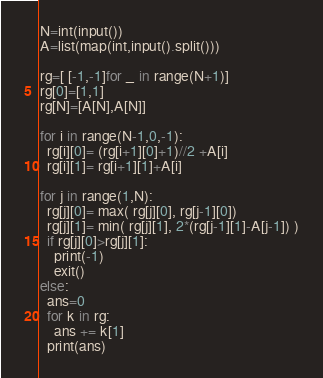Convert code to text. <code><loc_0><loc_0><loc_500><loc_500><_Python_>N=int(input())
A=list(map(int,input().split()))

rg=[ [-1,-1]for _ in range(N+1)]
rg[0]=[1,1]
rg[N]=[A[N],A[N]]

for i in range(N-1,0,-1):
  rg[i][0]= (rg[i+1][0]+1)//2 +A[i]
  rg[i][1]= rg[i+1][1]+A[i]
  
for j in range(1,N):
  rg[j][0]= max( rg[j][0], rg[j-1][0])
  rg[j][1]= min( rg[j][1], 2*(rg[j-1][1]-A[j-1]) )
  if rg[j][0]>rg[j][1]:
    print(-1)
    exit()
else:
  ans=0
  for k in rg:
    ans += k[1]
  print(ans)</code> 